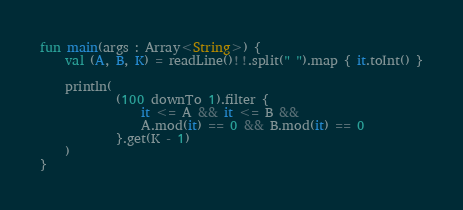<code> <loc_0><loc_0><loc_500><loc_500><_Kotlin_>fun main(args : Array<String>) {
    val (A, B, K) = readLine()!!.split(" ").map { it.toInt() }

    println(
            (100 downTo 1).filter {
                it <= A && it <= B &&
                A.mod(it) == 0 && B.mod(it) == 0
            }.get(K - 1)
    )
}</code> 